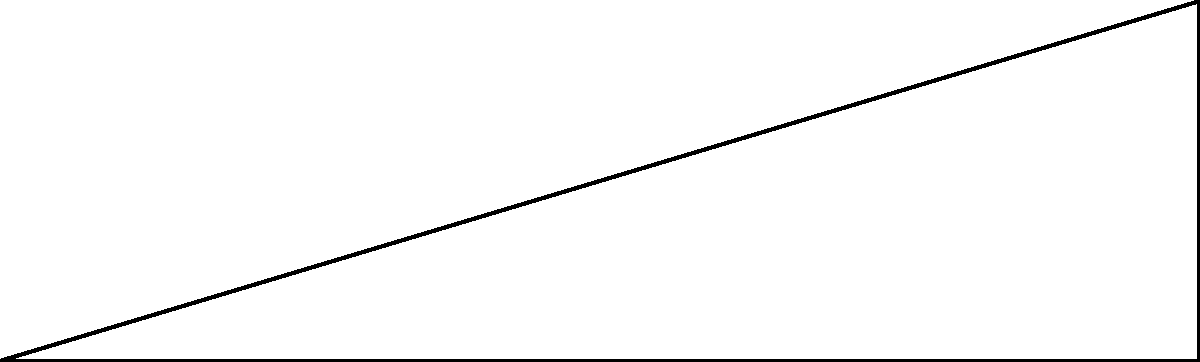During a traditional festival, you notice a tall tower used for the celebration. Standing 30 meters away from the base of the tower, you measure the angle of elevation to the top of the tower to be 60°. What is the height of the festival tower? Let's approach this step-by-step:

1) We can use the tangent function to solve this problem. In a right triangle, tangent is the ratio of the opposite side to the adjacent side.

2) In this case:
   - The adjacent side is the distance from you to the base of the tower (30 m)
   - The opposite side is the height of the tower (what we're trying to find)
   - The angle of elevation is 60°

3) Let's call the height of the tower $h$. We can write the equation:

   $$\tan(60°) = \frac{h}{30}$$

4) We know that $\tan(60°) = \sqrt{3}$, so we can rewrite the equation:

   $$\sqrt{3} = \frac{h}{30}$$

5) To solve for $h$, multiply both sides by 30:

   $$30\sqrt{3} = h$$

6) Simplify:

   $$h \approx 51.96 \text{ meters}$$

Therefore, the height of the festival tower is approximately 51.96 meters.
Answer: $30\sqrt{3} \approx 51.96 \text{ meters}$ 